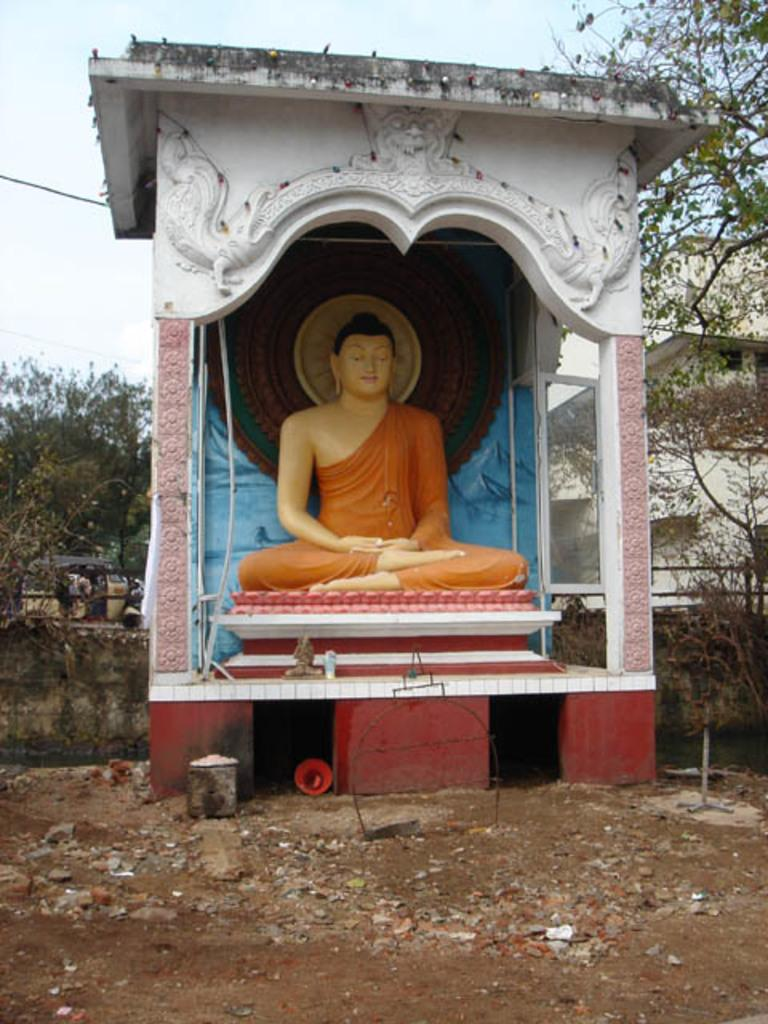What is the main subject in the image? There is a statue in the image. What can be seen in the background of the image? There are trees, a vehicle, and a building visible in the background of the image. How many times does the statue look at the plantation in the image? There is no plantation present in the image, and therefore the statue cannot look at it. 